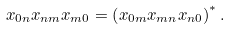Convert formula to latex. <formula><loc_0><loc_0><loc_500><loc_500>x _ { 0 n } x _ { n m } x _ { m 0 } = \left ( x _ { 0 m } x _ { m n } x _ { n 0 } \right ) ^ { * } .</formula> 